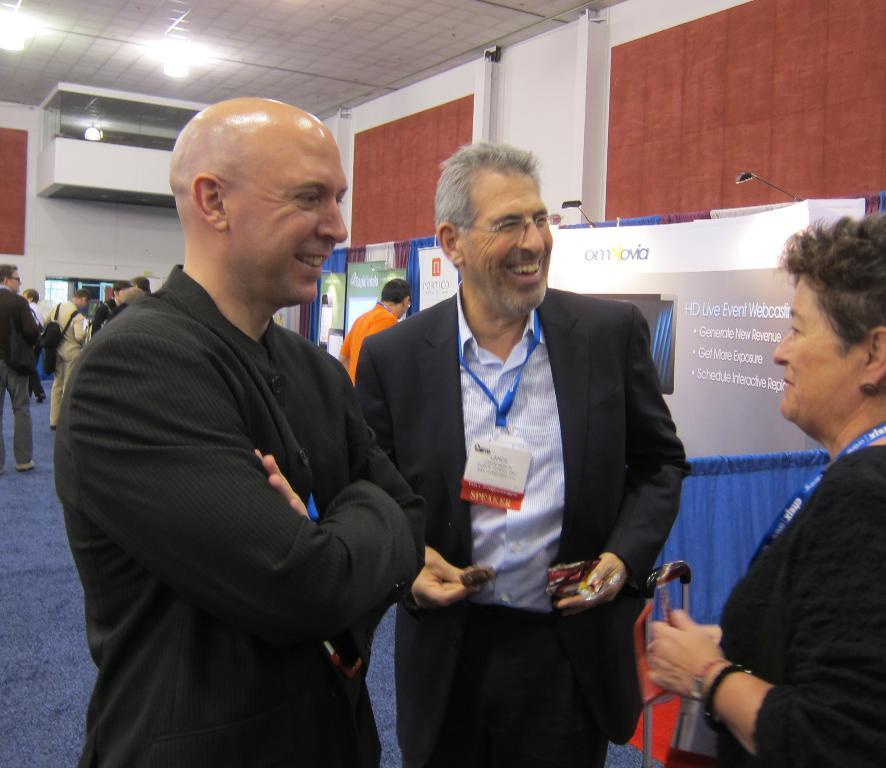How many people are in the image? There are three people in the image. What are the people doing in the image? The people are standing and smiling. What can be seen hanging in the image? There are banners in the image. What is visible in the background of the image? There is a wall in the background of the image. What type of lighting is present in the image? There are lights attached to the ceiling in the image. Can you tell me what type of self the people are taking in the image? There is no self-taking activity depicted in the image; the people are simply standing and smiling. What type of donkey can be seen in the image? There is no donkey present in the image. What type of owl is perched on the wall in the image? There is no owl present in the image; only the people, banners, wall, and lights are visible. 